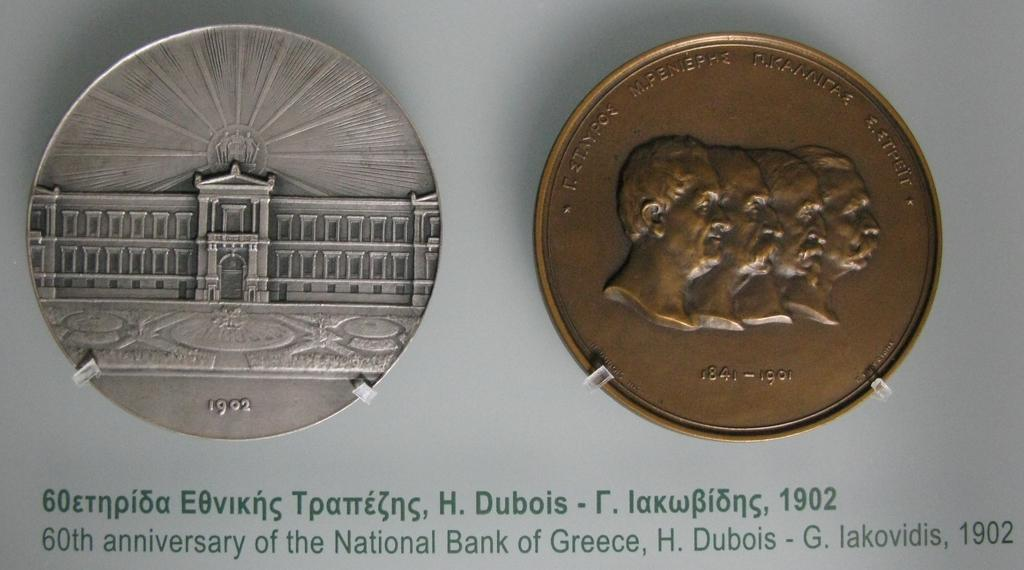<image>
Summarize the visual content of the image. the year 1902 is below the dark coin 